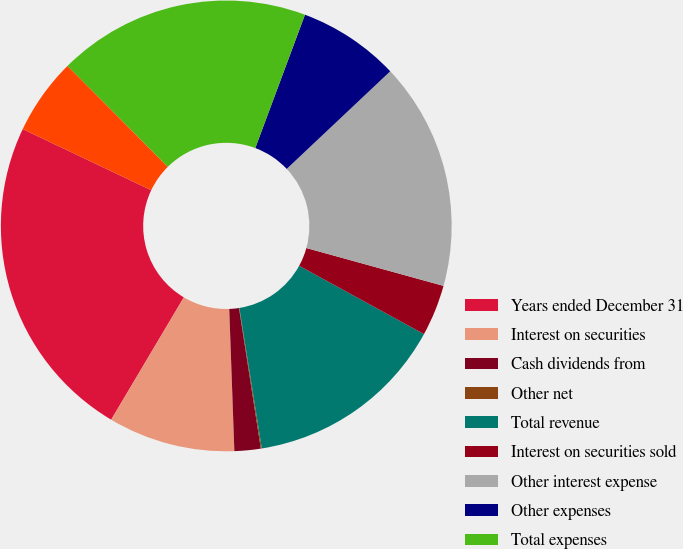Convert chart to OTSL. <chart><loc_0><loc_0><loc_500><loc_500><pie_chart><fcel>Years ended December 31<fcel>Interest on securities<fcel>Cash dividends from<fcel>Other net<fcel>Total revenue<fcel>Interest on securities sold<fcel>Other interest expense<fcel>Other expenses<fcel>Total expenses<fcel>Income tax benefit<nl><fcel>23.54%<fcel>9.1%<fcel>1.88%<fcel>0.07%<fcel>14.51%<fcel>3.68%<fcel>16.32%<fcel>7.29%<fcel>18.12%<fcel>5.49%<nl></chart> 